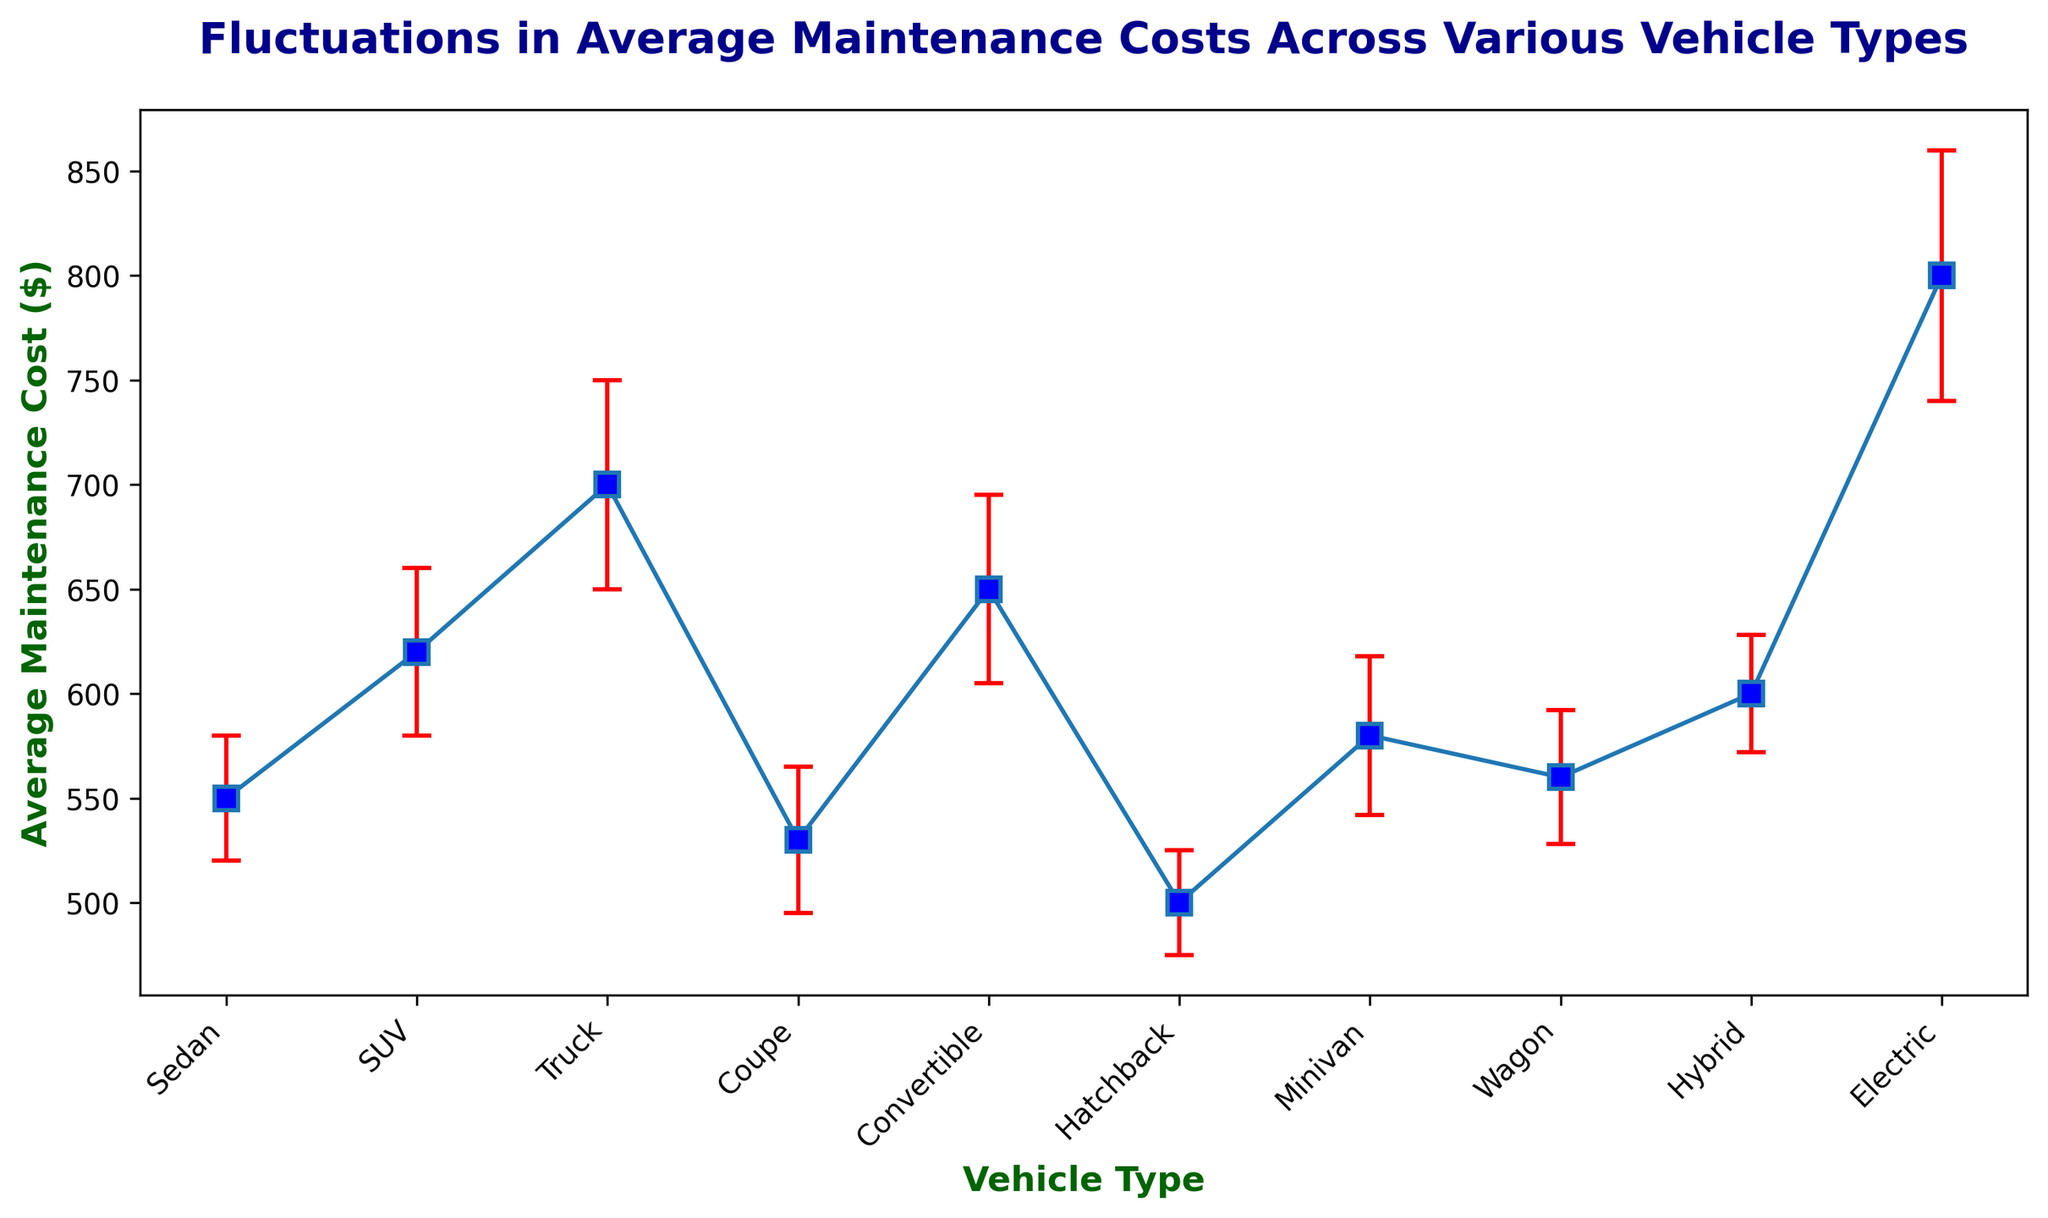What is the vehicle type with the lowest average maintenance cost? To find the vehicle type with the lowest average maintenance cost, look for the shortest height among the data points representing the average maintenance cost. This would correspond to 'Hatchback' with an average cost of $500.
Answer: Hatchback Which two vehicle types have the most similar average maintenance costs? Compare the heights of the data points in the figure. 'Sedan' and 'Wagon' have similar heights indicating that their average maintenance costs are $550 and $560, respectively. The difference between them is minimal.
Answer: Sedan and Wagon What is the difference in average maintenance cost between trucks and sedans? Look at the heights of the data points for Truck and Sedan. Truck has an average maintenance cost of $700 and Sedan has $550. The difference is 700 - 550.
Answer: 150 Among SUV, Convertible, and Hybrid, which has the highest average maintenance cost? Compare the heights of data points for SUV, Convertible, and Hybrid. SUV has $620, Convertible has $650, and Hybrid has $600. Convertible has the highest among these.
Answer: Convertible What is the range of average maintenance costs for all vehicle types shown in the figure? Identify the highest and lowest average maintenance costs in the figure. The highest is for Electric at $800, and the lowest is for Hatchback at $500. The range is 800 - 500.
Answer: 300 Which vehicle type has the largest standard error in its average maintenance cost? Look for the data point with the longest error bar. The longest error bar is for Electric with a standard error of $60.
Answer: Electric What is the average maintenance cost of Minivan plus twice the standard error of Coupe? The average maintenance cost of Minivan is $580, and the standard error of Coupe is $35. The required value is 580 + 2*35.
Answer: 650 How does the average maintenance cost of Electric compare to the sum of the average maintenance costs of Coupe and Wagon? Add the average maintenance costs of Coupe ($530) and Wagon ($560). The combined cost is 530 + 560 = 1090. Electric's average maintenance cost is $800, which is less than the combined cost.
Answer: Less than Is there any vehicle type with an average maintenance cost and estimated variation (standard error) that does not overlap with any other vehicle's error bars? Examine the error bars on each data point to see where they might overlap. Look for any unique or isolated points. 'Electric' with an average maintenance cost of $800 and standard error of $60 does not overlap with other error bars as it sits above all.
Answer: Electric Compare the robustness of maintenance cost estimates between Hybrid and SUV by comparing their standard errors. Check the lengths of the error bars for Hybrid and SUV. Hybrid has a standard error of $28, while SUV has $40. Hybrid has a smaller standard error indicating a more precise estimate.
Answer: Hybrid 